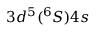<formula> <loc_0><loc_0><loc_500><loc_500>3 d ^ { 5 } ( ^ { 6 } S ) 4 s</formula> 